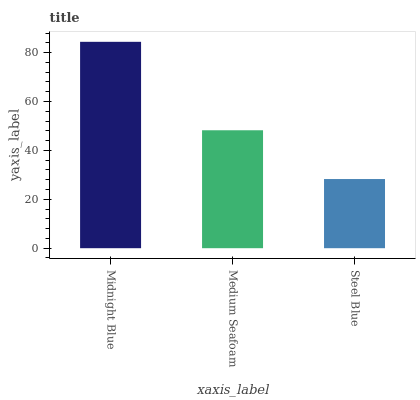Is Medium Seafoam the minimum?
Answer yes or no. No. Is Medium Seafoam the maximum?
Answer yes or no. No. Is Midnight Blue greater than Medium Seafoam?
Answer yes or no. Yes. Is Medium Seafoam less than Midnight Blue?
Answer yes or no. Yes. Is Medium Seafoam greater than Midnight Blue?
Answer yes or no. No. Is Midnight Blue less than Medium Seafoam?
Answer yes or no. No. Is Medium Seafoam the high median?
Answer yes or no. Yes. Is Medium Seafoam the low median?
Answer yes or no. Yes. Is Midnight Blue the high median?
Answer yes or no. No. Is Steel Blue the low median?
Answer yes or no. No. 